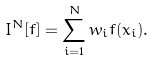<formula> <loc_0><loc_0><loc_500><loc_500>I ^ { N } [ f ] = \sum _ { i = 1 } ^ { N } w _ { i } f ( { x } _ { i } ) .</formula> 